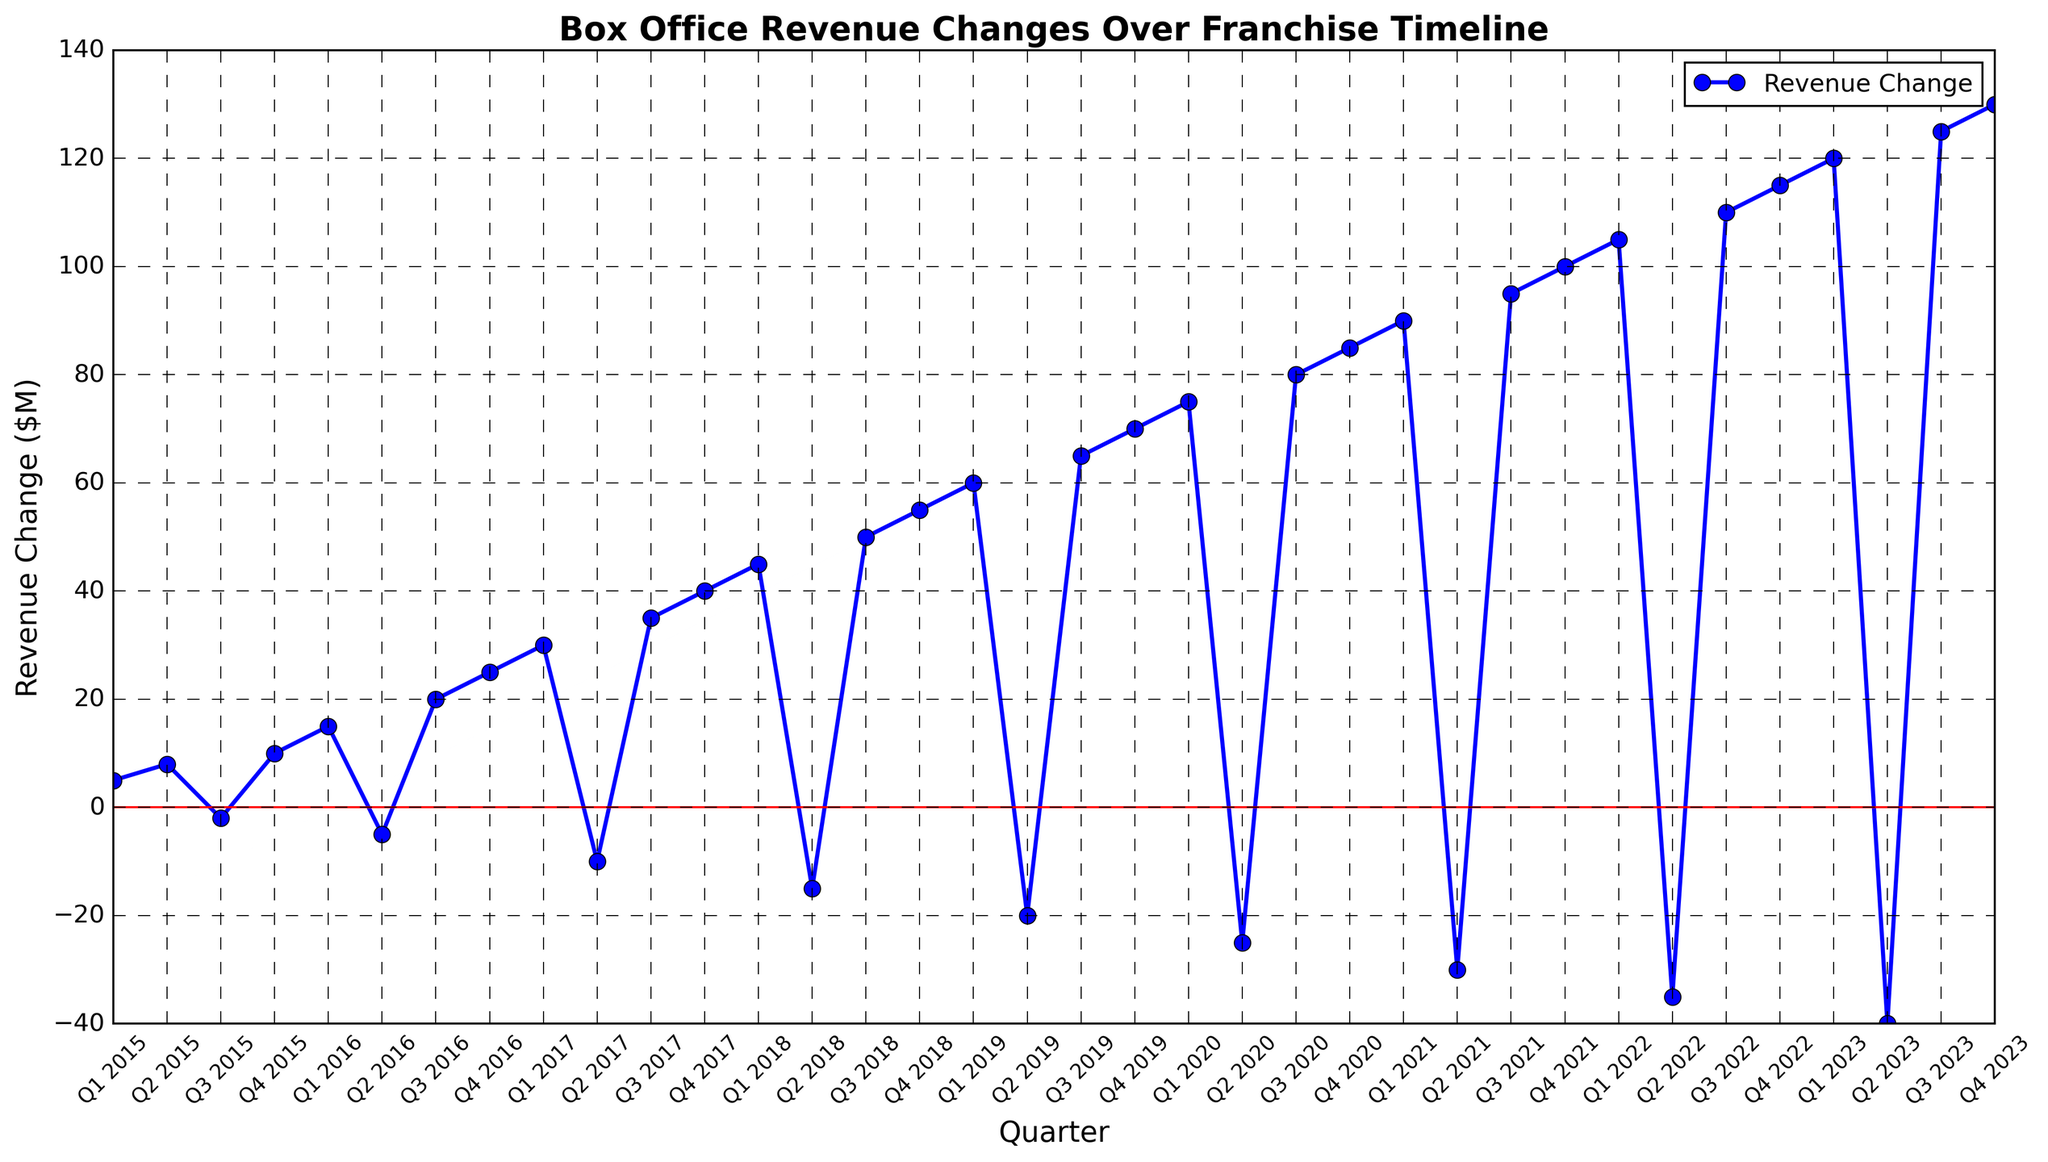What is the overall trend in revenue changes from Q1 2015 to Q4 2023? The overall trend in the plot indicates an increasing box office revenue change over the timeline, as the values generally ascend from a revenue change of $5M in Q1 2015 to $130M in Q4 2023 despite periodic drops.
Answer: Increasing What is the revenue change in Q1 2020, and how does it compare to Q2 2020? The revenue change in Q1 2020 is $75M, whereas in Q2 2020, it drops to -$25M. This shows a decrease of $100M between the two quarters.
Answer: $100M decrease Which quarter shows the highest positive revenue change? The highest positive revenue change is in Q4 2023, marked at $130M.
Answer: Q4 2023 Identify two quarters with the largest drop in revenue change. The largest drops in revenue change occur between Q1 2022 to Q2 2022 ($105M to -$35M) and Q2 2023 to Q3 2023 (-$40M to $125M). These are the largest negative shifts seen on the plot.
Answer: Q1 2022 to Q2 2022, and Q2 2023 to Q3 2023 What is the total revenue change for the year 2021? Sum the revenue changes for each quarter in 2021: Q1 ($90M), Q2 (-$30M), Q3 ($95M), Q4 ($100M). Hence, the total is 90 - 30 + 95 + 100 = $255M.
Answer: $255M Which period of the timeline sees the first instance of negative revenue change? The first instance of negative revenue change is observed in Q3 2015, where the value drops to -$2M.
Answer: Q3 2015 How does the revenue change compare between Q4 2017 and Q4 2018? In Q4 2017, the revenue change is $40M, whereas, in Q4 2018, it is $55M, indicating an increase of $15M from the previous year.
Answer: Increase by $15M What's the average revenue change in 2020? Sum up the revenue changes for 2020: Q1 ($75M), Q2 (-$25M), Q3 ($80M), Q4 ($85M). Then, divide by 4: (75 - 25 + 80 + 85) / 4 = 215 / 4 = $53.75M.
Answer: $53.75M Was there any quarter showing no change in revenue compared to the previous one? The visual inspection shows none of the quarters have a revenue change equal to their preceding quarter; all quarters display some change, either positive or negative.
Answer: No Which quarter shows the maximum revenue change after a negative quarter in 2019? After Q2 2019, which has a revenue change of -$20M, Q3 2019 shows a change of $65M. So, the maximum positive change after a negative quarter in 2019 is in Q3 2019.
Answer: Q3 2019 